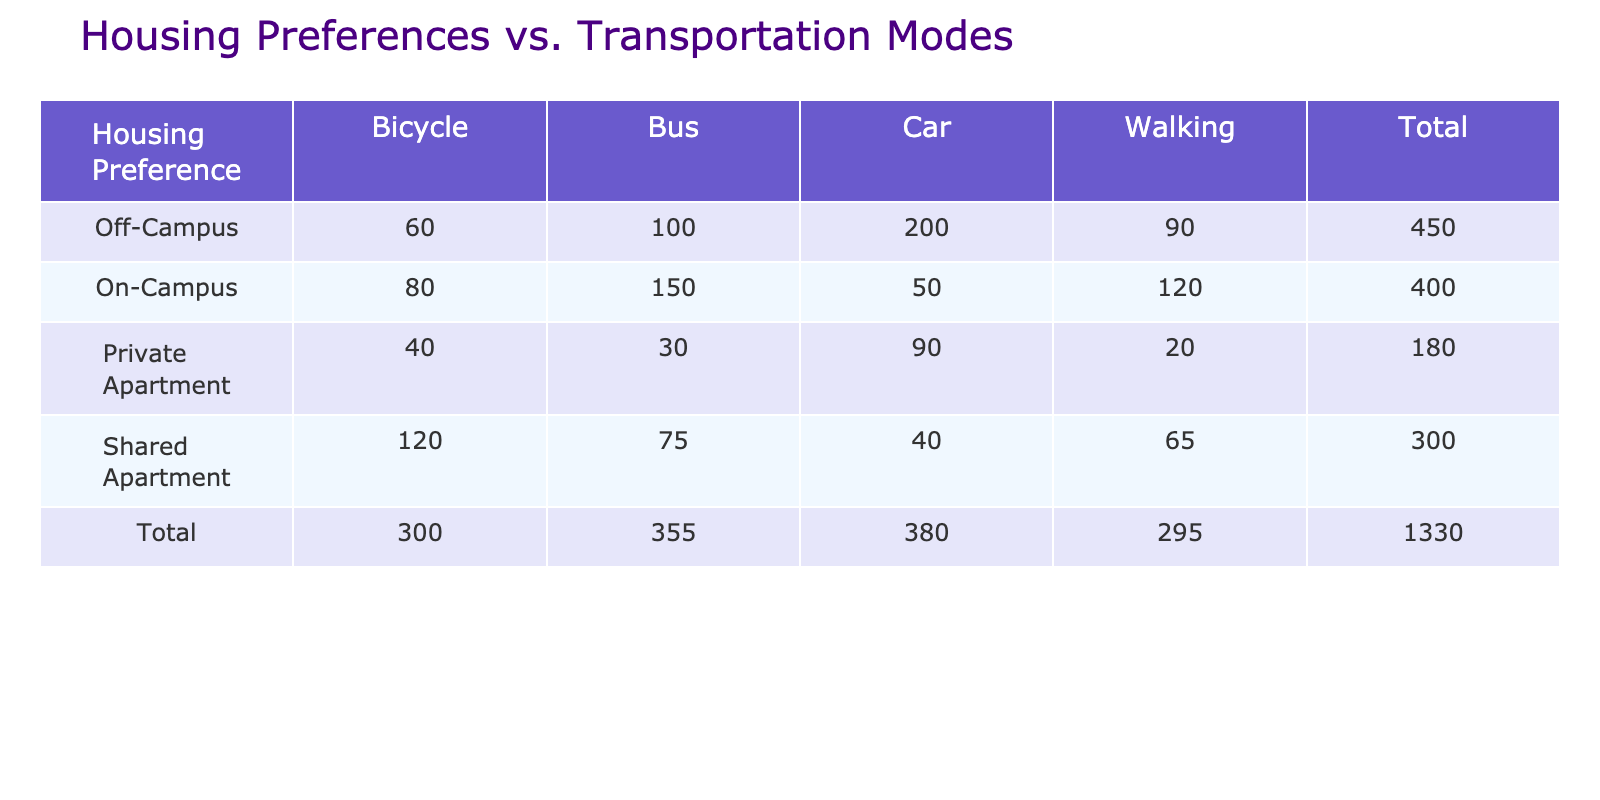What is the total count of students living in a Private Apartment who use the Car for transportation? In the table, under the 'Private Apartment' row, the count corresponding to 'Car' is given as 90. Thus, this is the total count of students living in a Private Apartment using Car for transportation.
Answer: 90 How many students prefer the Bus for transportation if they live in Shared Apartments? Looking under the 'Shared Apartment' row and 'Bus' column, the count is 75. This number directly indicates how many students prefer the Bus while living in Shared Apartments.
Answer: 75 Are more students who live Off-Campus using Cars compared to those living On-Campus? For 'Off-Campus', the count for 'Car' is 200 while for 'On-Campus' it is 50. Since 200 is greater than 50, the answer is yes, more Off-Campus students use Cars.
Answer: Yes What is the total number of students who walk, regardless of their housing preference? To find the total who walk, we sum the counts for 'Walking' across all housing preferences: On-Campus (120) + Off-Campus (90) + Shared Apartment (65) + Private Apartment (20) = 295. This total provides the number of students who walk for transportation.
Answer: 295 What mode of transportation is preferred by students living in Off-Campus housing, based on the data? The highest count in the 'Off-Campus' row is related to the 'Car' mode with 200 students, indicating that this is the preferred transportation mode among Off-Campus students.
Answer: Car How many total students prefer Bicycles across all housing preferences? Summing up the counts for 'Bicycle': On-Campus (80) + Off-Campus (60) + Shared Apartment (120) + Private Apartment (40) gives us a total of 300, which shows the overall preference for Bicycles among students.
Answer: 300 Is the count of students using the Bus higher among On-Campus residents compared to those in Private Apartments? The counts show 150 for 'On-Campus' and 30 for 'Private Apartment' using the Bus. Since 150 is greater than 30, it confirms that On-Campus students do prefer the Bus more than Private Apartment residents.
Answer: Yes What is the difference in the number of students walking between those living Off-Campus and Shared Apartments? Referring to the 'Walking' counts, Off-Campus has 90 and Shared Apartments have 65. The difference is calculated as 90 - 65 = 25, which indicates how many more Off-Campus students walk compared to Shared Apartment students.
Answer: 25 